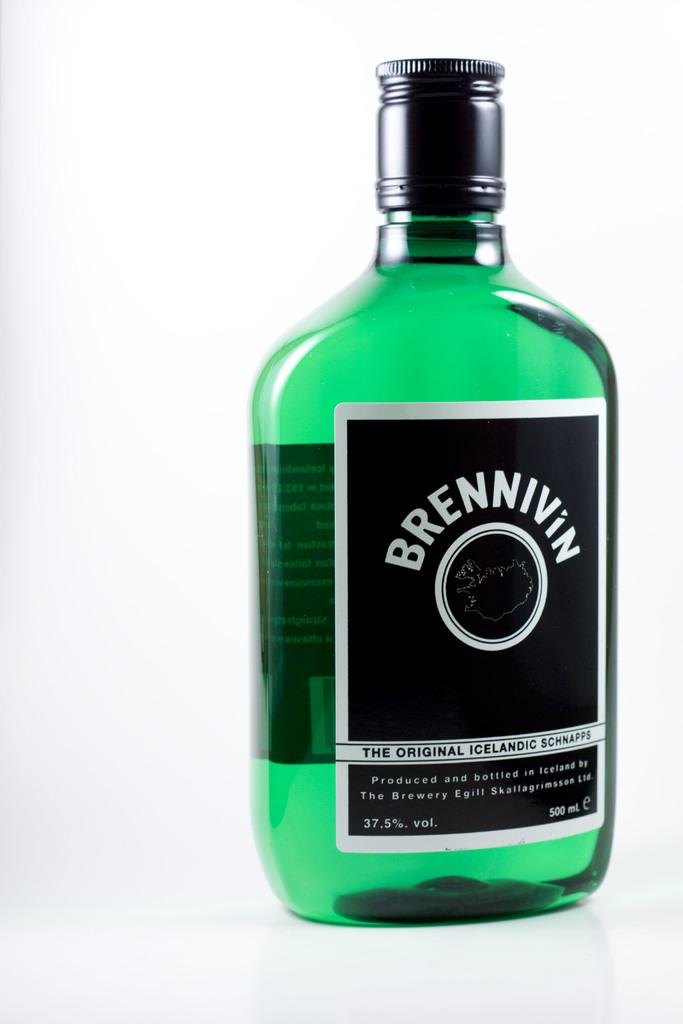What does it say on the white letter?
Offer a very short reply. Brennivin. 